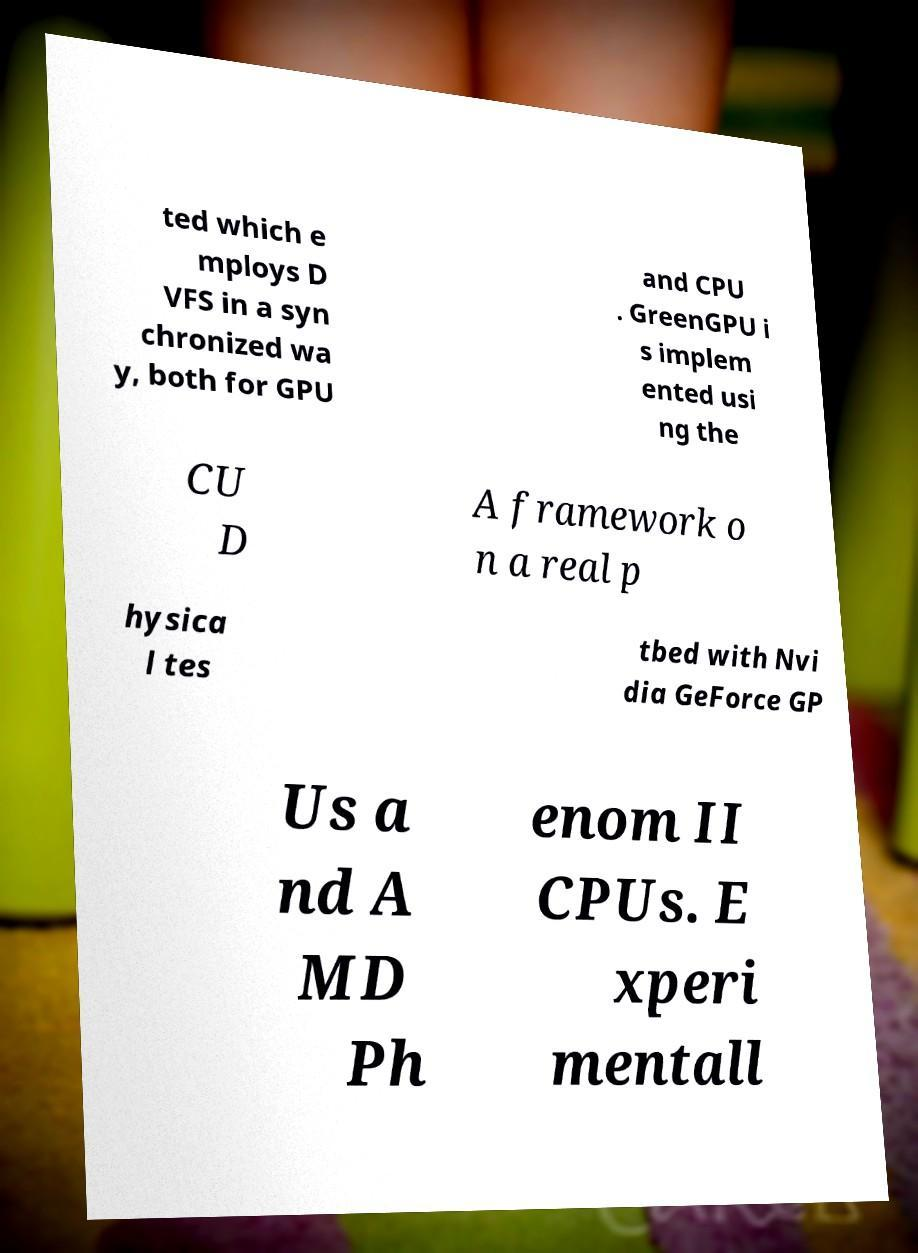Can you read and provide the text displayed in the image?This photo seems to have some interesting text. Can you extract and type it out for me? ted which e mploys D VFS in a syn chronized wa y, both for GPU and CPU . GreenGPU i s implem ented usi ng the CU D A framework o n a real p hysica l tes tbed with Nvi dia GeForce GP Us a nd A MD Ph enom II CPUs. E xperi mentall 